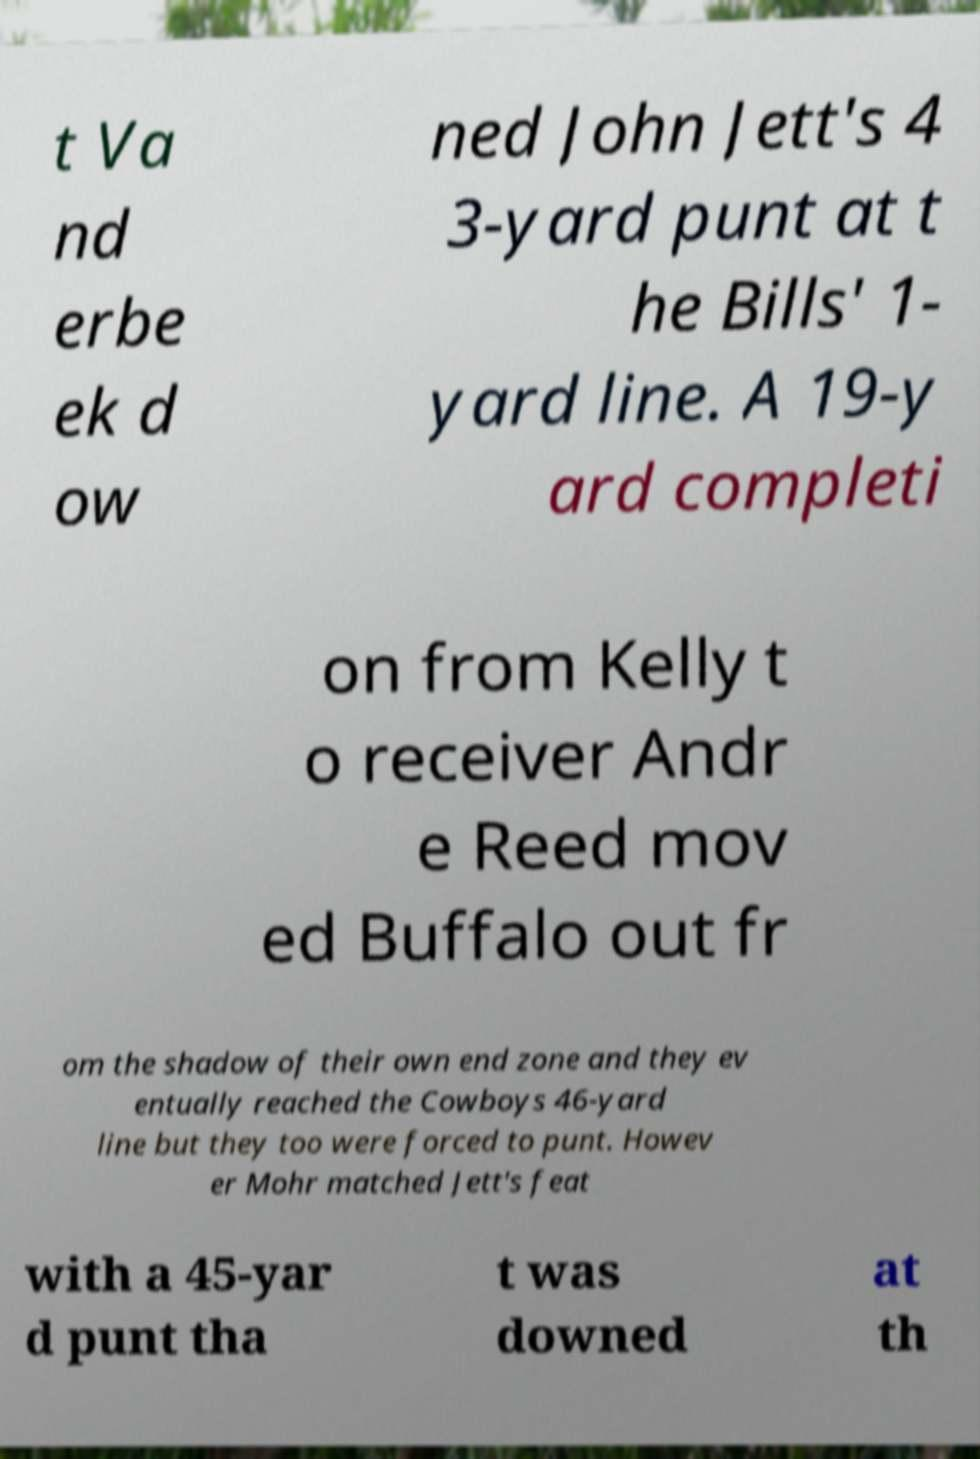For documentation purposes, I need the text within this image transcribed. Could you provide that? t Va nd erbe ek d ow ned John Jett's 4 3-yard punt at t he Bills' 1- yard line. A 19-y ard completi on from Kelly t o receiver Andr e Reed mov ed Buffalo out fr om the shadow of their own end zone and they ev entually reached the Cowboys 46-yard line but they too were forced to punt. Howev er Mohr matched Jett's feat with a 45-yar d punt tha t was downed at th 